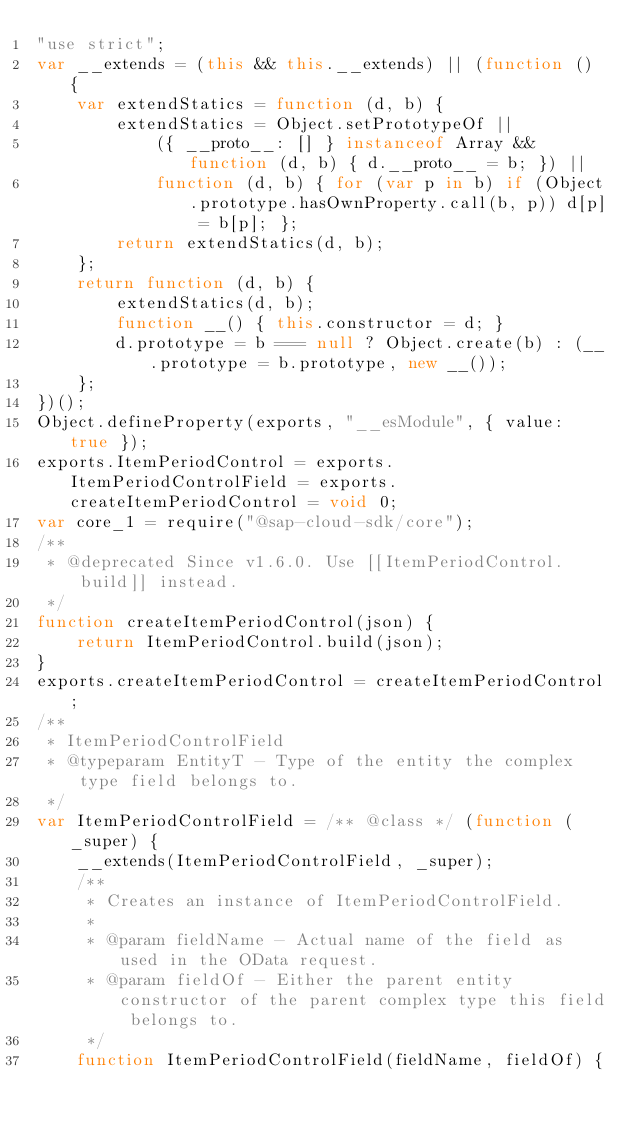<code> <loc_0><loc_0><loc_500><loc_500><_JavaScript_>"use strict";
var __extends = (this && this.__extends) || (function () {
    var extendStatics = function (d, b) {
        extendStatics = Object.setPrototypeOf ||
            ({ __proto__: [] } instanceof Array && function (d, b) { d.__proto__ = b; }) ||
            function (d, b) { for (var p in b) if (Object.prototype.hasOwnProperty.call(b, p)) d[p] = b[p]; };
        return extendStatics(d, b);
    };
    return function (d, b) {
        extendStatics(d, b);
        function __() { this.constructor = d; }
        d.prototype = b === null ? Object.create(b) : (__.prototype = b.prototype, new __());
    };
})();
Object.defineProperty(exports, "__esModule", { value: true });
exports.ItemPeriodControl = exports.ItemPeriodControlField = exports.createItemPeriodControl = void 0;
var core_1 = require("@sap-cloud-sdk/core");
/**
 * @deprecated Since v1.6.0. Use [[ItemPeriodControl.build]] instead.
 */
function createItemPeriodControl(json) {
    return ItemPeriodControl.build(json);
}
exports.createItemPeriodControl = createItemPeriodControl;
/**
 * ItemPeriodControlField
 * @typeparam EntityT - Type of the entity the complex type field belongs to.
 */
var ItemPeriodControlField = /** @class */ (function (_super) {
    __extends(ItemPeriodControlField, _super);
    /**
     * Creates an instance of ItemPeriodControlField.
     *
     * @param fieldName - Actual name of the field as used in the OData request.
     * @param fieldOf - Either the parent entity constructor of the parent complex type this field belongs to.
     */
    function ItemPeriodControlField(fieldName, fieldOf) {</code> 